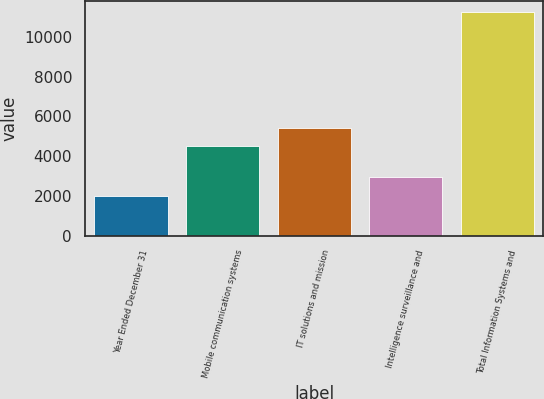Convert chart. <chart><loc_0><loc_0><loc_500><loc_500><bar_chart><fcel>Year Ended December 31<fcel>Mobile communication systems<fcel>IT solutions and mission<fcel>Intelligence surveillance and<fcel>Total Information Systems and<nl><fcel>2011<fcel>4511<fcel>5432<fcel>2932<fcel>11221<nl></chart> 